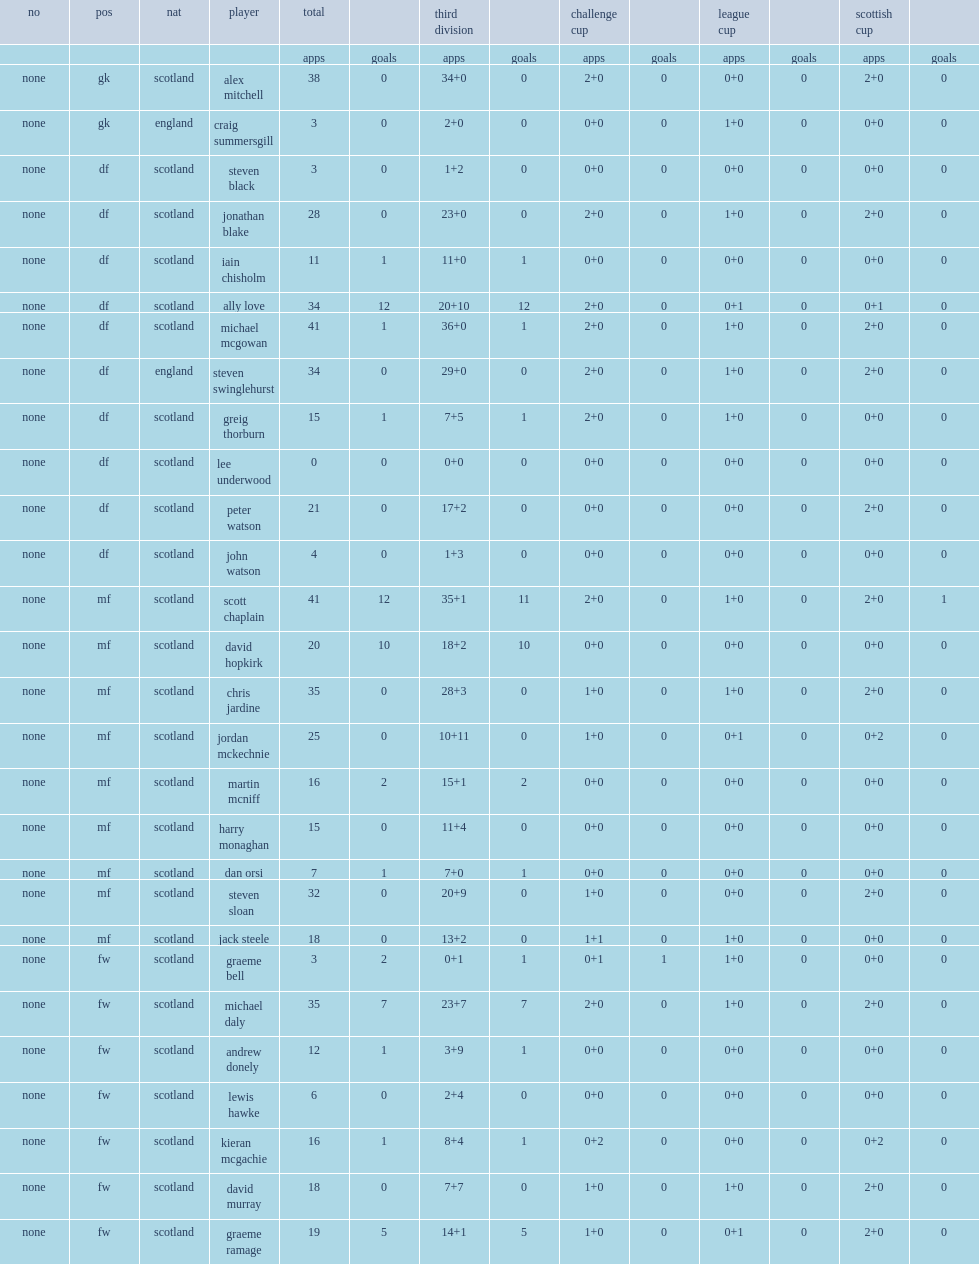List the matches that annan competed in. Challenge cup league cup scottish cup. 